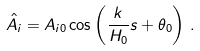Convert formula to latex. <formula><loc_0><loc_0><loc_500><loc_500>\hat { A } _ { i } = A _ { i 0 } \cos \left ( \frac { k } { H _ { 0 } } s + \theta _ { 0 } \right ) \, .</formula> 